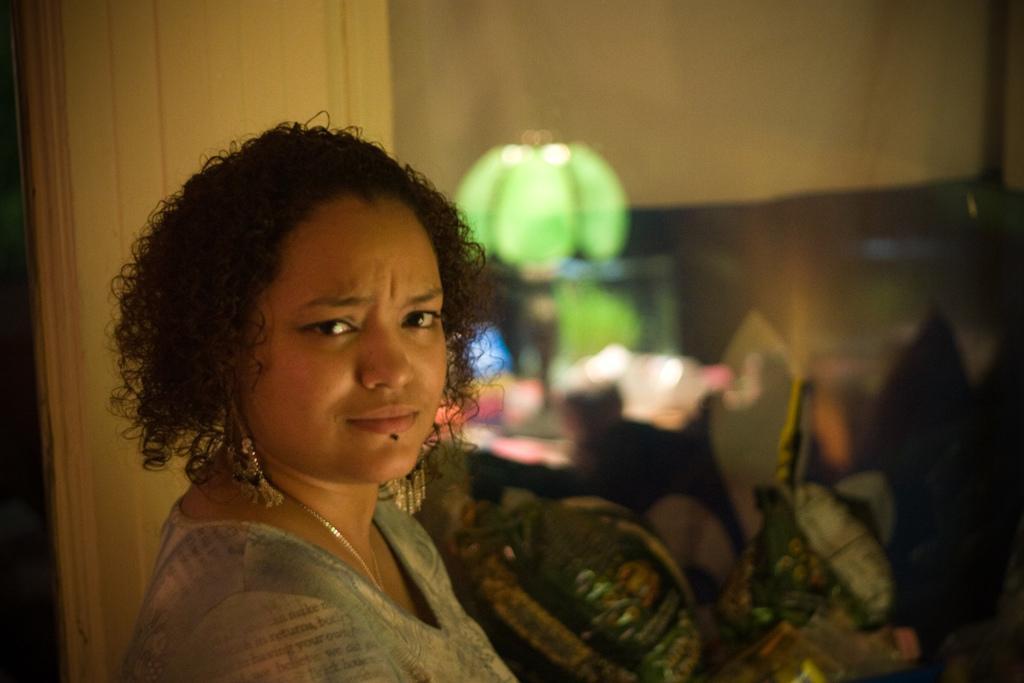Can you describe this image briefly? In this image there is a woman in the middle. In the background there is a green colour lamp on the table. On the left side there is a wall behind her. 